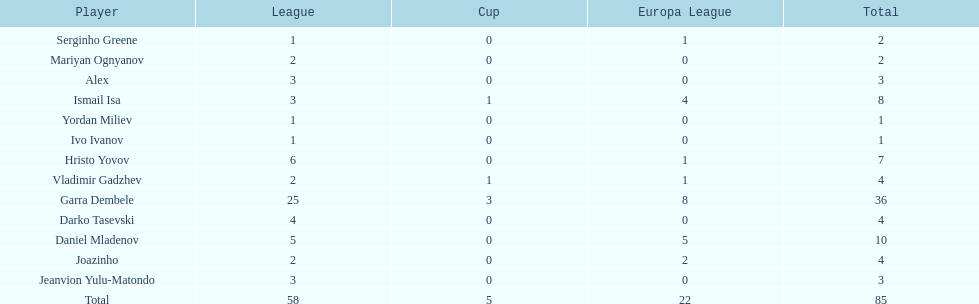How many of the players did not score any goals in the cup? 10. 